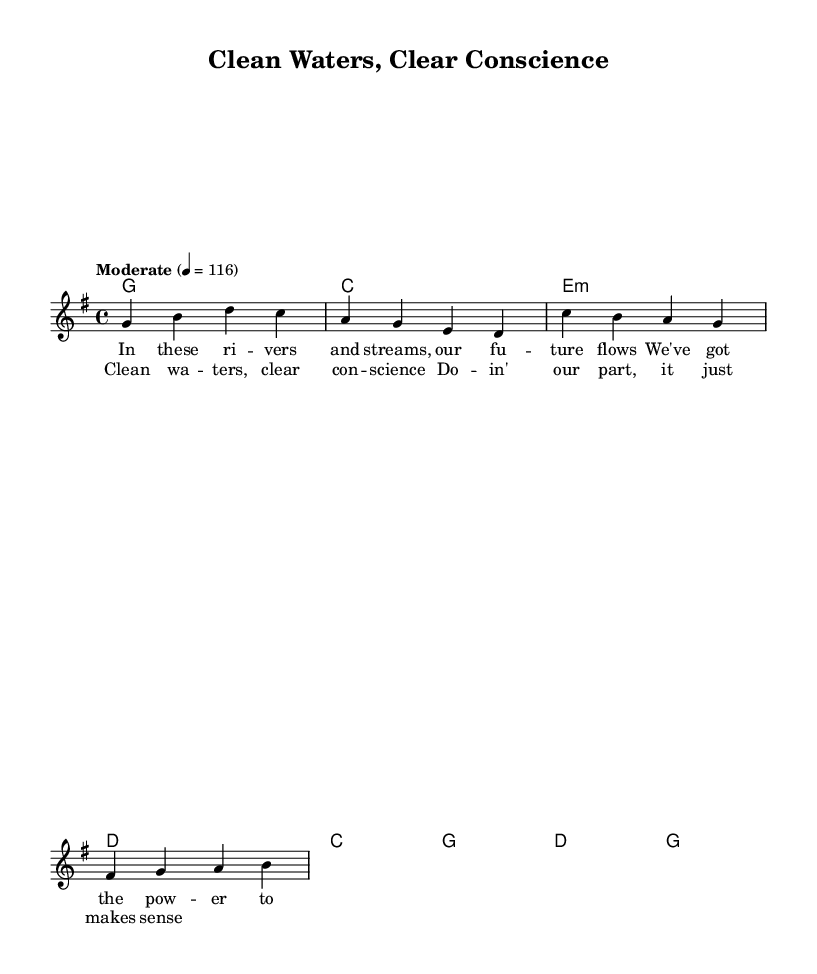What is the key signature of this music? The key signature is G major, which has one sharp (F#).
Answer: G major What is the time signature of this music? The time signature is 4/4, indicating four beats per measure.
Answer: 4/4 What is the tempo marking of this piece? The tempo marking indicates a moderate speed, specifically set at 116 beats per minute.
Answer: Moderate 116 How many measures are in the verse? The verse consists of two measures, as indicated by the number of bars provided in the melody section.
Answer: 2 What is the first note of the chorus? The first note of the chorus is C, as shown in the melody line for the chorus section.
Answer: C What theme does the lyrics focus on? The theme of the lyrics focuses on environmental responsibility, particularly regarding clean water.
Answer: Environmental responsibility How many chords are used in the verse harmony? The verse uses four distinct chords: G, C, E minor, and D.
Answer: 4 